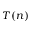Convert formula to latex. <formula><loc_0><loc_0><loc_500><loc_500>T ( n )</formula> 